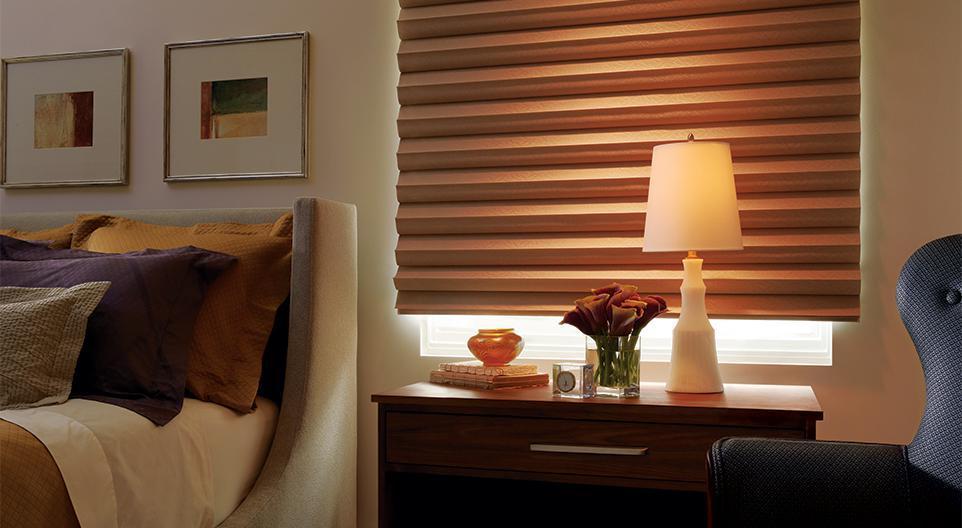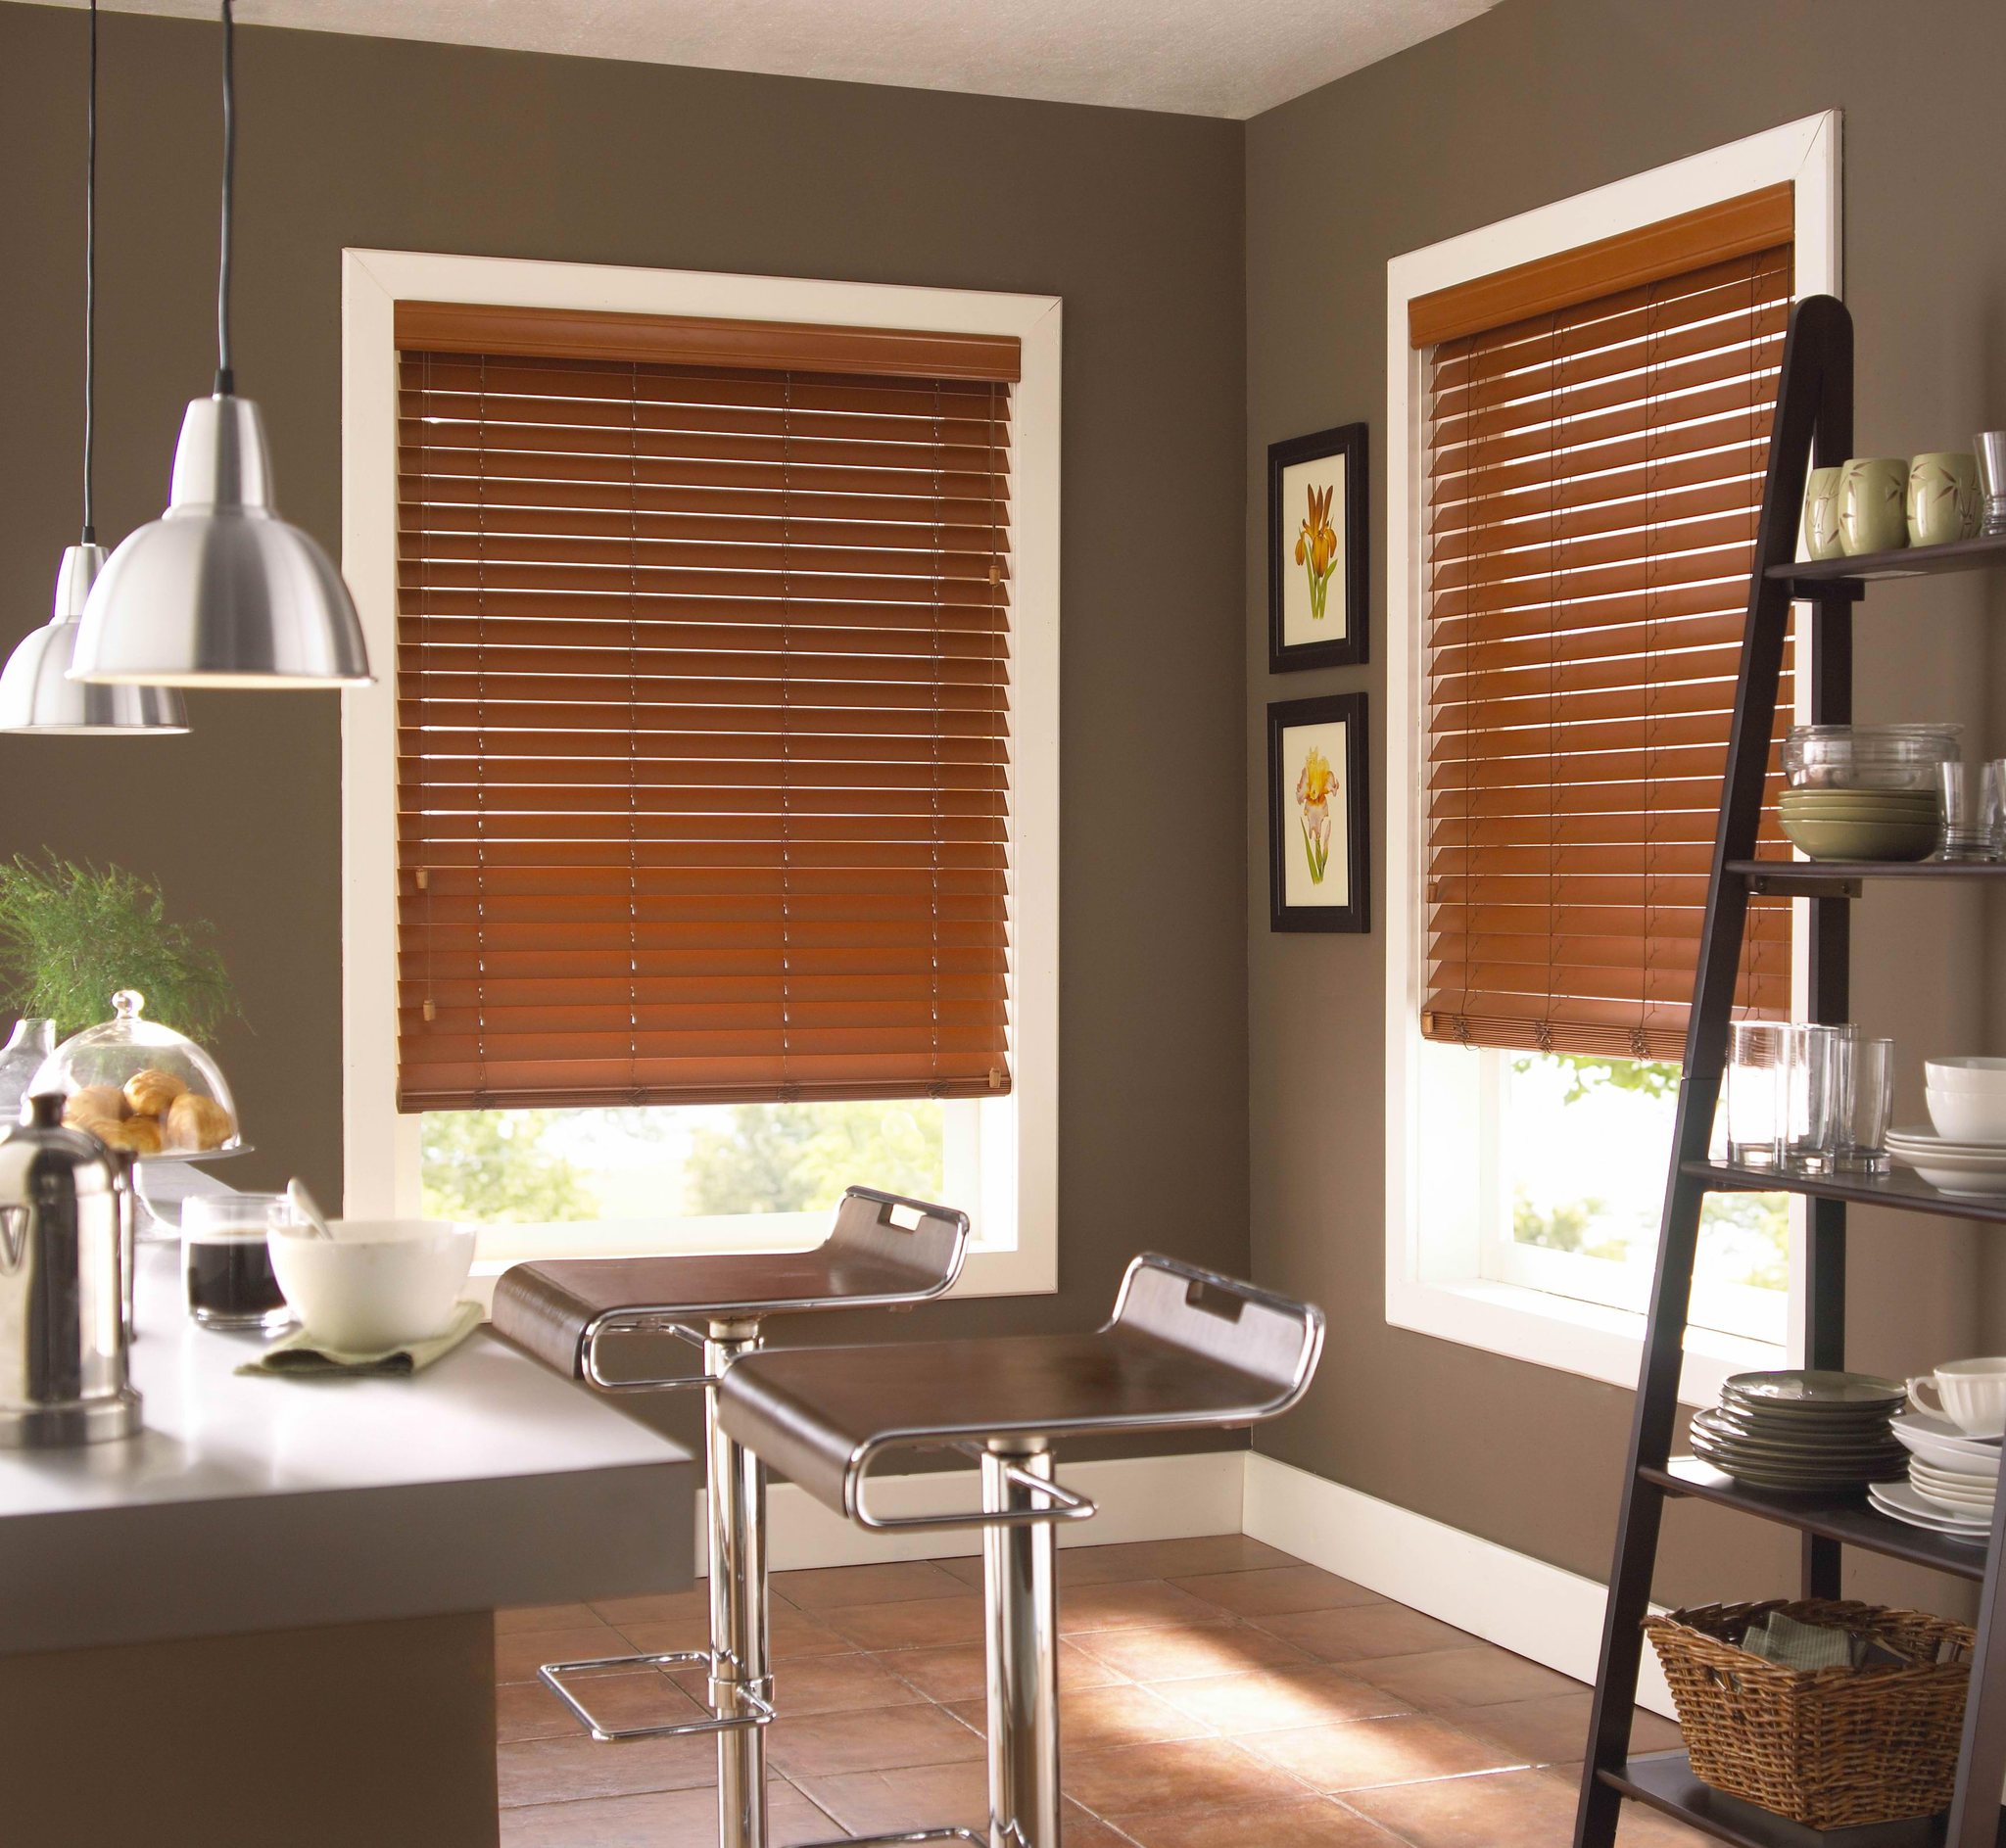The first image is the image on the left, the second image is the image on the right. For the images displayed, is the sentence "There are exactly two window shades in the right image." factually correct? Answer yes or no. Yes. The first image is the image on the left, the second image is the image on the right. Evaluate the accuracy of this statement regarding the images: "There is a total of three blinds.". Is it true? Answer yes or no. Yes. 